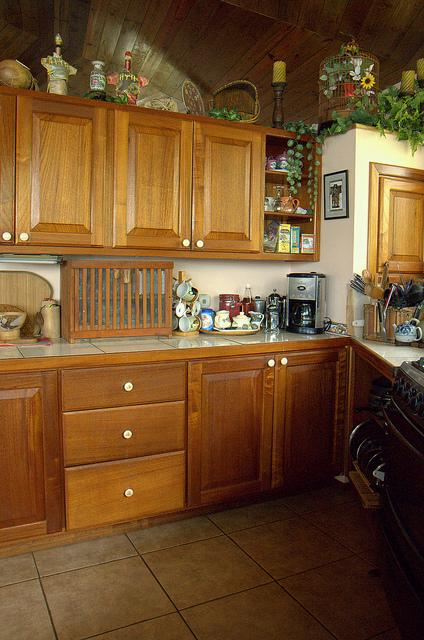How many drawers are in the bottom cabinet of this kitchen?

Choices:
A) four
B) two
C) one
D) three three 